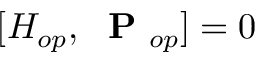Convert formula to latex. <formula><loc_0><loc_0><loc_500><loc_500>[ H _ { o p } , P _ { o p } ] = 0</formula> 